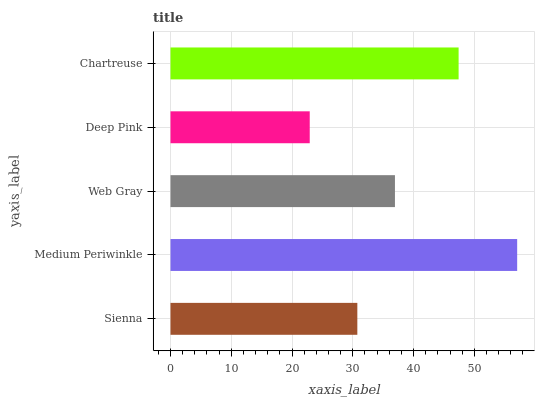Is Deep Pink the minimum?
Answer yes or no. Yes. Is Medium Periwinkle the maximum?
Answer yes or no. Yes. Is Web Gray the minimum?
Answer yes or no. No. Is Web Gray the maximum?
Answer yes or no. No. Is Medium Periwinkle greater than Web Gray?
Answer yes or no. Yes. Is Web Gray less than Medium Periwinkle?
Answer yes or no. Yes. Is Web Gray greater than Medium Periwinkle?
Answer yes or no. No. Is Medium Periwinkle less than Web Gray?
Answer yes or no. No. Is Web Gray the high median?
Answer yes or no. Yes. Is Web Gray the low median?
Answer yes or no. Yes. Is Medium Periwinkle the high median?
Answer yes or no. No. Is Deep Pink the low median?
Answer yes or no. No. 